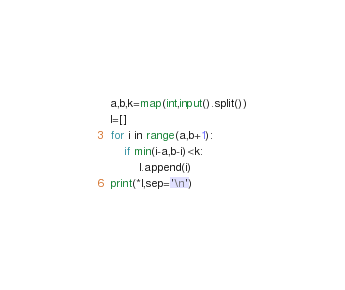Convert code to text. <code><loc_0><loc_0><loc_500><loc_500><_Python_>a,b,k=map(int,input().split())
l=[]
for i in range(a,b+1):
	if min(i-a,b-i)<k:
		l.append(i)
print(*l,sep='\n')</code> 